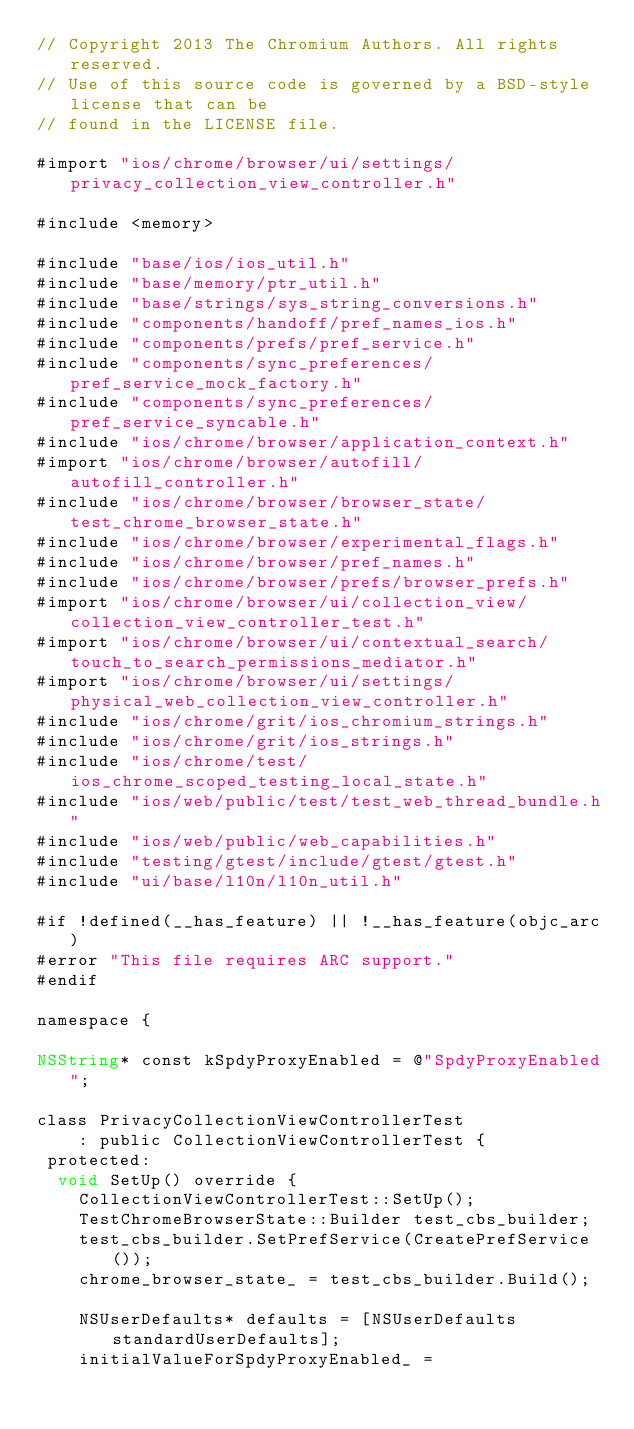Convert code to text. <code><loc_0><loc_0><loc_500><loc_500><_ObjectiveC_>// Copyright 2013 The Chromium Authors. All rights reserved.
// Use of this source code is governed by a BSD-style license that can be
// found in the LICENSE file.

#import "ios/chrome/browser/ui/settings/privacy_collection_view_controller.h"

#include <memory>

#include "base/ios/ios_util.h"
#include "base/memory/ptr_util.h"
#include "base/strings/sys_string_conversions.h"
#include "components/handoff/pref_names_ios.h"
#include "components/prefs/pref_service.h"
#include "components/sync_preferences/pref_service_mock_factory.h"
#include "components/sync_preferences/pref_service_syncable.h"
#include "ios/chrome/browser/application_context.h"
#import "ios/chrome/browser/autofill/autofill_controller.h"
#include "ios/chrome/browser/browser_state/test_chrome_browser_state.h"
#include "ios/chrome/browser/experimental_flags.h"
#include "ios/chrome/browser/pref_names.h"
#include "ios/chrome/browser/prefs/browser_prefs.h"
#import "ios/chrome/browser/ui/collection_view/collection_view_controller_test.h"
#import "ios/chrome/browser/ui/contextual_search/touch_to_search_permissions_mediator.h"
#import "ios/chrome/browser/ui/settings/physical_web_collection_view_controller.h"
#include "ios/chrome/grit/ios_chromium_strings.h"
#include "ios/chrome/grit/ios_strings.h"
#include "ios/chrome/test/ios_chrome_scoped_testing_local_state.h"
#include "ios/web/public/test/test_web_thread_bundle.h"
#include "ios/web/public/web_capabilities.h"
#include "testing/gtest/include/gtest/gtest.h"
#include "ui/base/l10n/l10n_util.h"

#if !defined(__has_feature) || !__has_feature(objc_arc)
#error "This file requires ARC support."
#endif

namespace {

NSString* const kSpdyProxyEnabled = @"SpdyProxyEnabled";

class PrivacyCollectionViewControllerTest
    : public CollectionViewControllerTest {
 protected:
  void SetUp() override {
    CollectionViewControllerTest::SetUp();
    TestChromeBrowserState::Builder test_cbs_builder;
    test_cbs_builder.SetPrefService(CreatePrefService());
    chrome_browser_state_ = test_cbs_builder.Build();

    NSUserDefaults* defaults = [NSUserDefaults standardUserDefaults];
    initialValueForSpdyProxyEnabled_ =</code> 